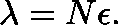Convert formula to latex. <formula><loc_0><loc_0><loc_500><loc_500>\lambda = N \epsilon .</formula> 